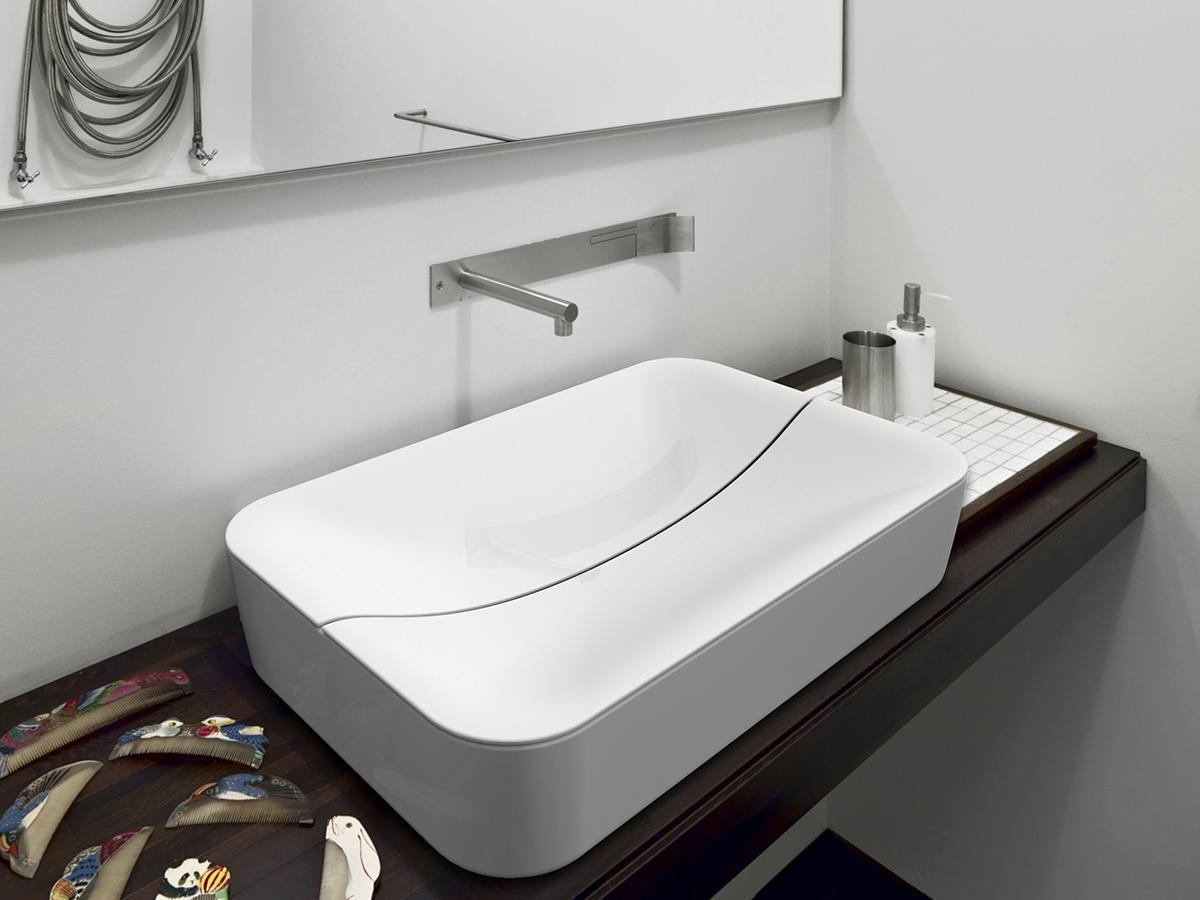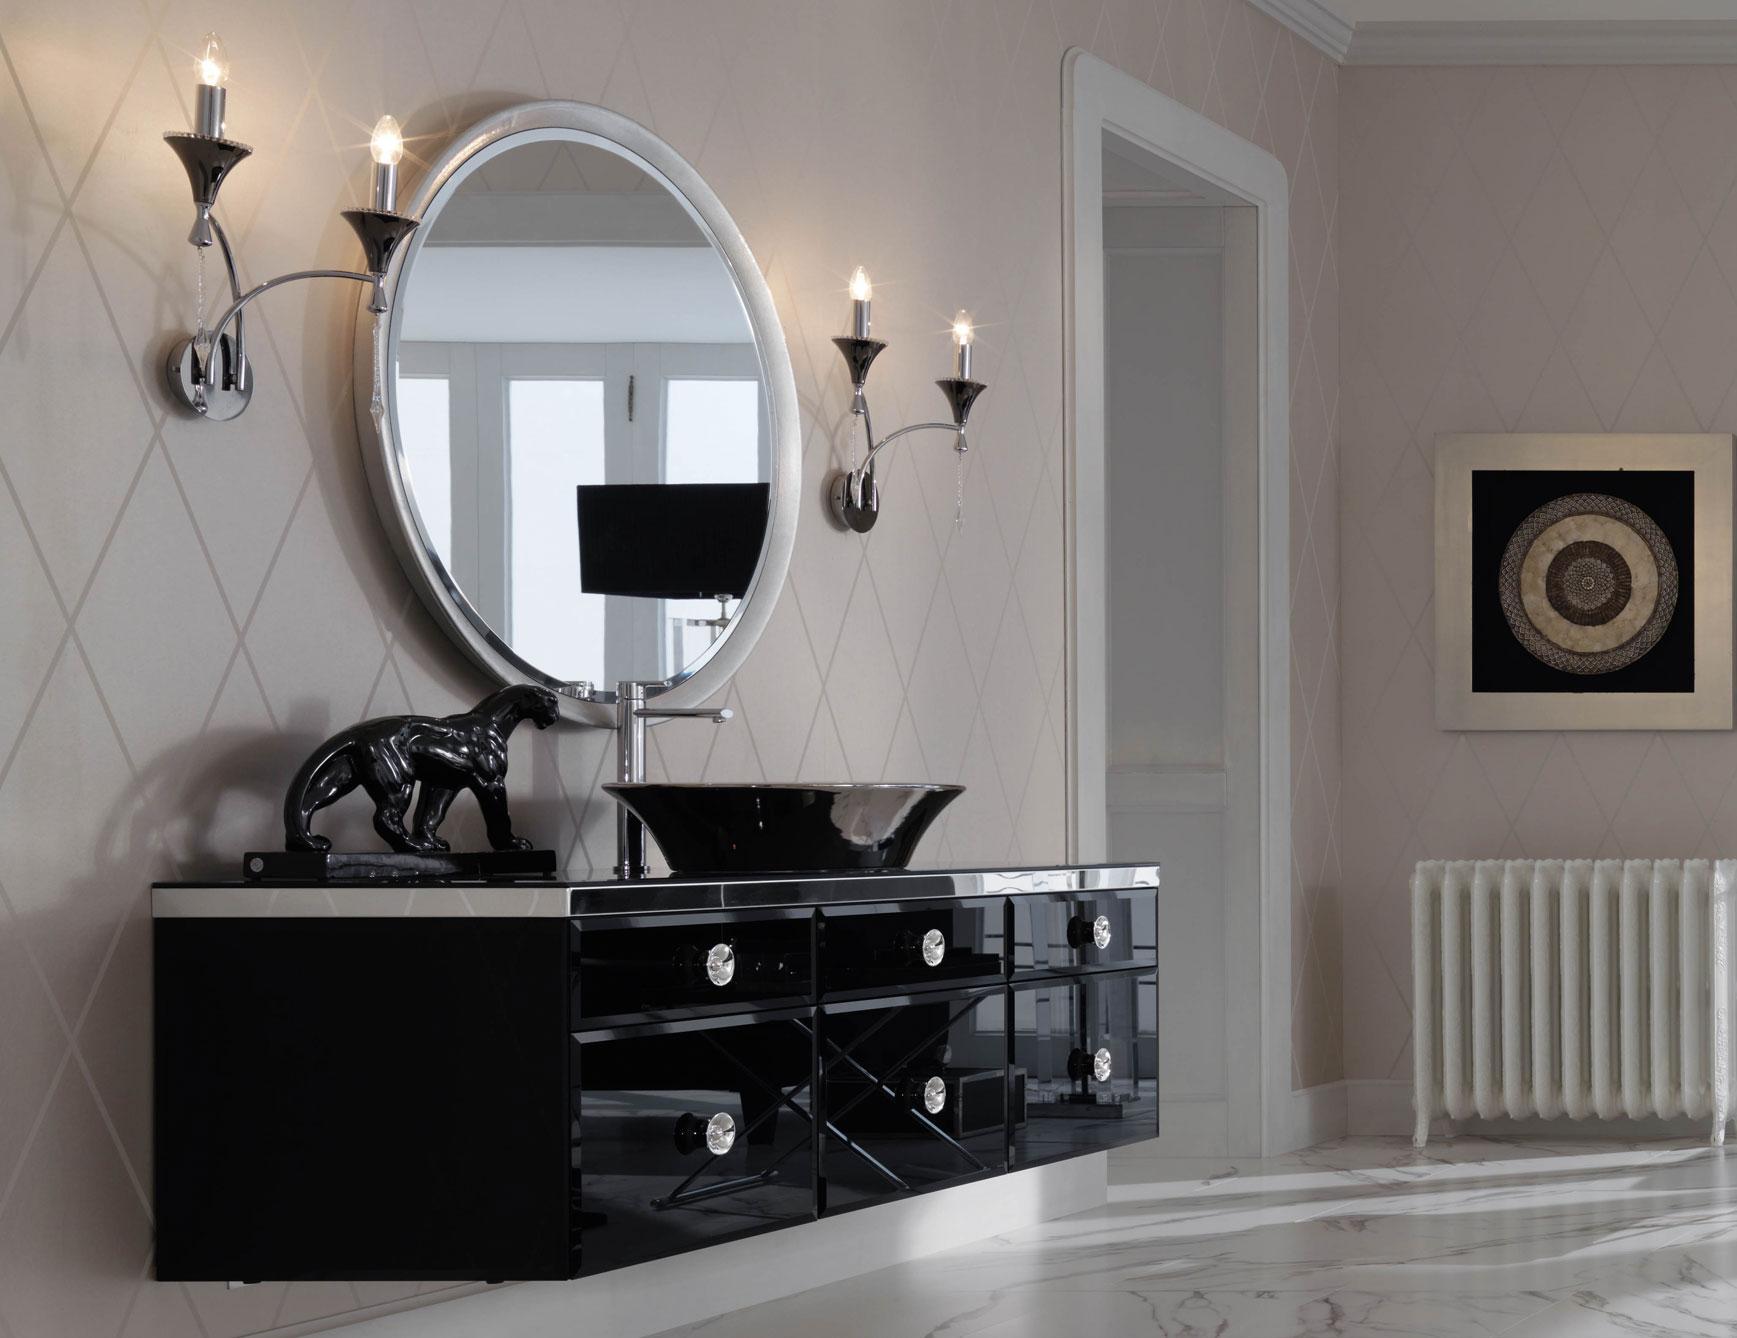The first image is the image on the left, the second image is the image on the right. Examine the images to the left and right. Is the description "One image shows a round mirror above a vessel sink on a vanity counter." accurate? Answer yes or no. Yes. The first image is the image on the left, the second image is the image on the right. For the images shown, is this caption "There are two sinks in the image on the left." true? Answer yes or no. No. 